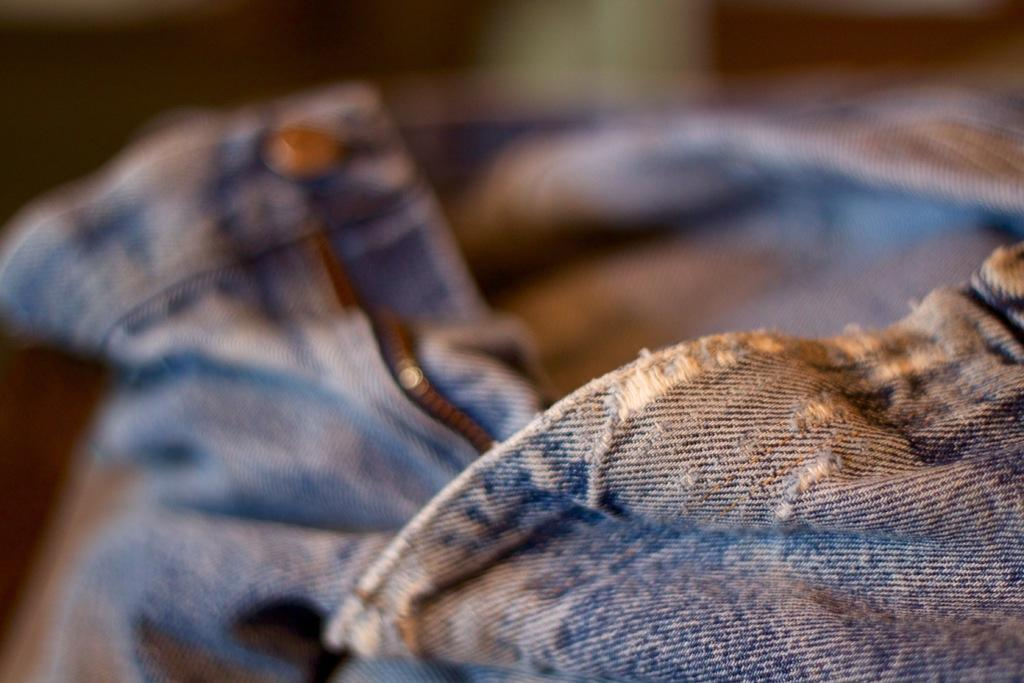What type of clothing item is visible in the image? There is a pair of jeans in the image. Can you describe the background of the image? The background of the image is blurred. What type of writing instrument is being used by the deer in the image? There is no deer present in the image, and therefore no writing instrument can be observed. 